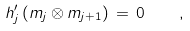Convert formula to latex. <formula><loc_0><loc_0><loc_500><loc_500>h _ { j } ^ { \prime } \, ( m _ { j } \otimes m _ { j + 1 } ) \, = \, 0 \quad ,</formula> 